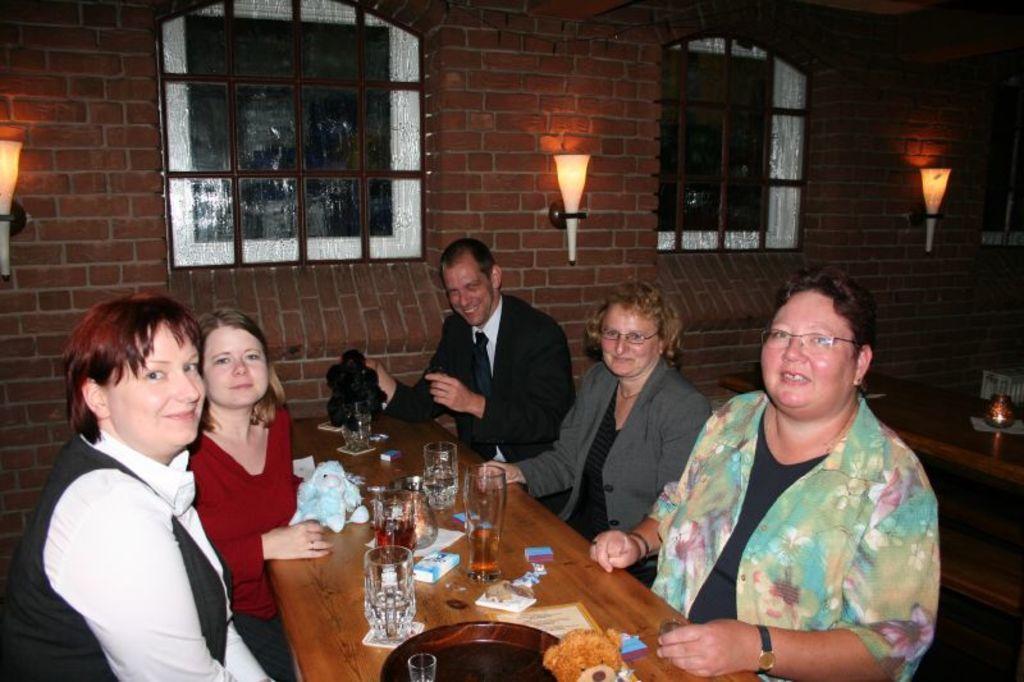Describe this image in one or two sentences. In this picture we can see a group of people sitting on chair and in front of them there is table and on table we can see glasses, boxes, teddy bear, plate, toys and in background we can see wall with windows, lamps attached to it. 